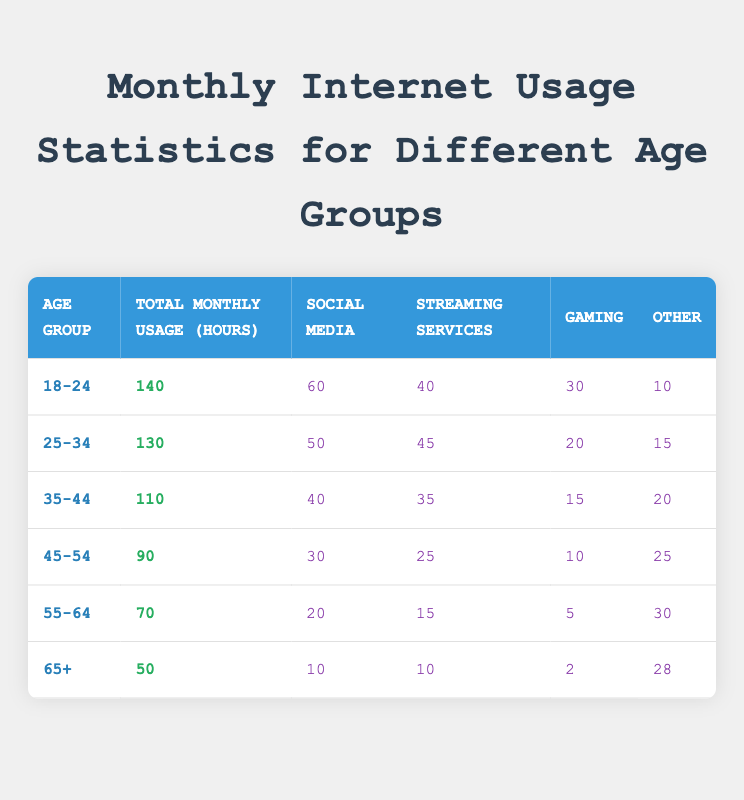What is the total monthly internet usage for the age group 35-44? The table lists the total monthly usage for different age groups. For the age group 35-44, the total monthly usage is found in the corresponding cell in the "Total Monthly Usage (hours)" column, which shows 110 hours.
Answer: 110 Which age group spends the most time on social media? To determine which age group spends the most time on social media, we can look at the "Social Media" column and find the highest value. The age group 18-24 has the highest value of 60 hours, which is greater than other age groups.
Answer: 18-24 How many total hours do age groups 25-34 and 35-44 spend on streaming services combined? First, identify the streaming service usage for both age groups. The 25-34 age group uses streaming services for 45 hours, and the 35-44 age group uses them for 35 hours. Adding these together gives 45 + 35 = 80 hours.
Answer: 80 Does the age group 55-64 spend more time on gaming than the group 45-54? We need to compare the gaming hours of both age groups. The 55-64 age group spends 5 hours on gaming while the 45-54 age group spends 10 hours. Since 5 is less than 10, the statement is false.
Answer: No What is the average total monthly internet usage across all age groups? To find the average, we'll sum the total monthly usage for all age groups: 140 + 130 + 110 + 90 + 70 + 50 = 690 hours. There are 6 age groups, so we divide 690 by 6. This gives an average usage of 115 hours.
Answer: 115 Which age group uses the least amount of hours on streaming services? The streaming service usage for all age groups is needed for comparison. The age group 65+ uses streaming services for 10 hours, which is lower than the other groups (20, 25, 30, 40, and 45 hours). Thus, the 65+ group uses the least.
Answer: 65+ What percentage of the total internet usage for the age group 18-24 is spent on social media? The total usage for 18-24 is 140 hours, and they spend 60 hours on social media. To find the percentage, divide 60 by 140 and multiply by 100: (60/140) * 100 = 42.857. This rounds to approximately 43%.
Answer: 43% Is it true that the age group 25-34 spends more hours on 'other' platforms than the age group 45-54? Checking the "Other" column, the 25-34 group spends 15 hours and the 45-54 group spends 25 hours. Since 15 is less than 25, the statement is false.
Answer: No 